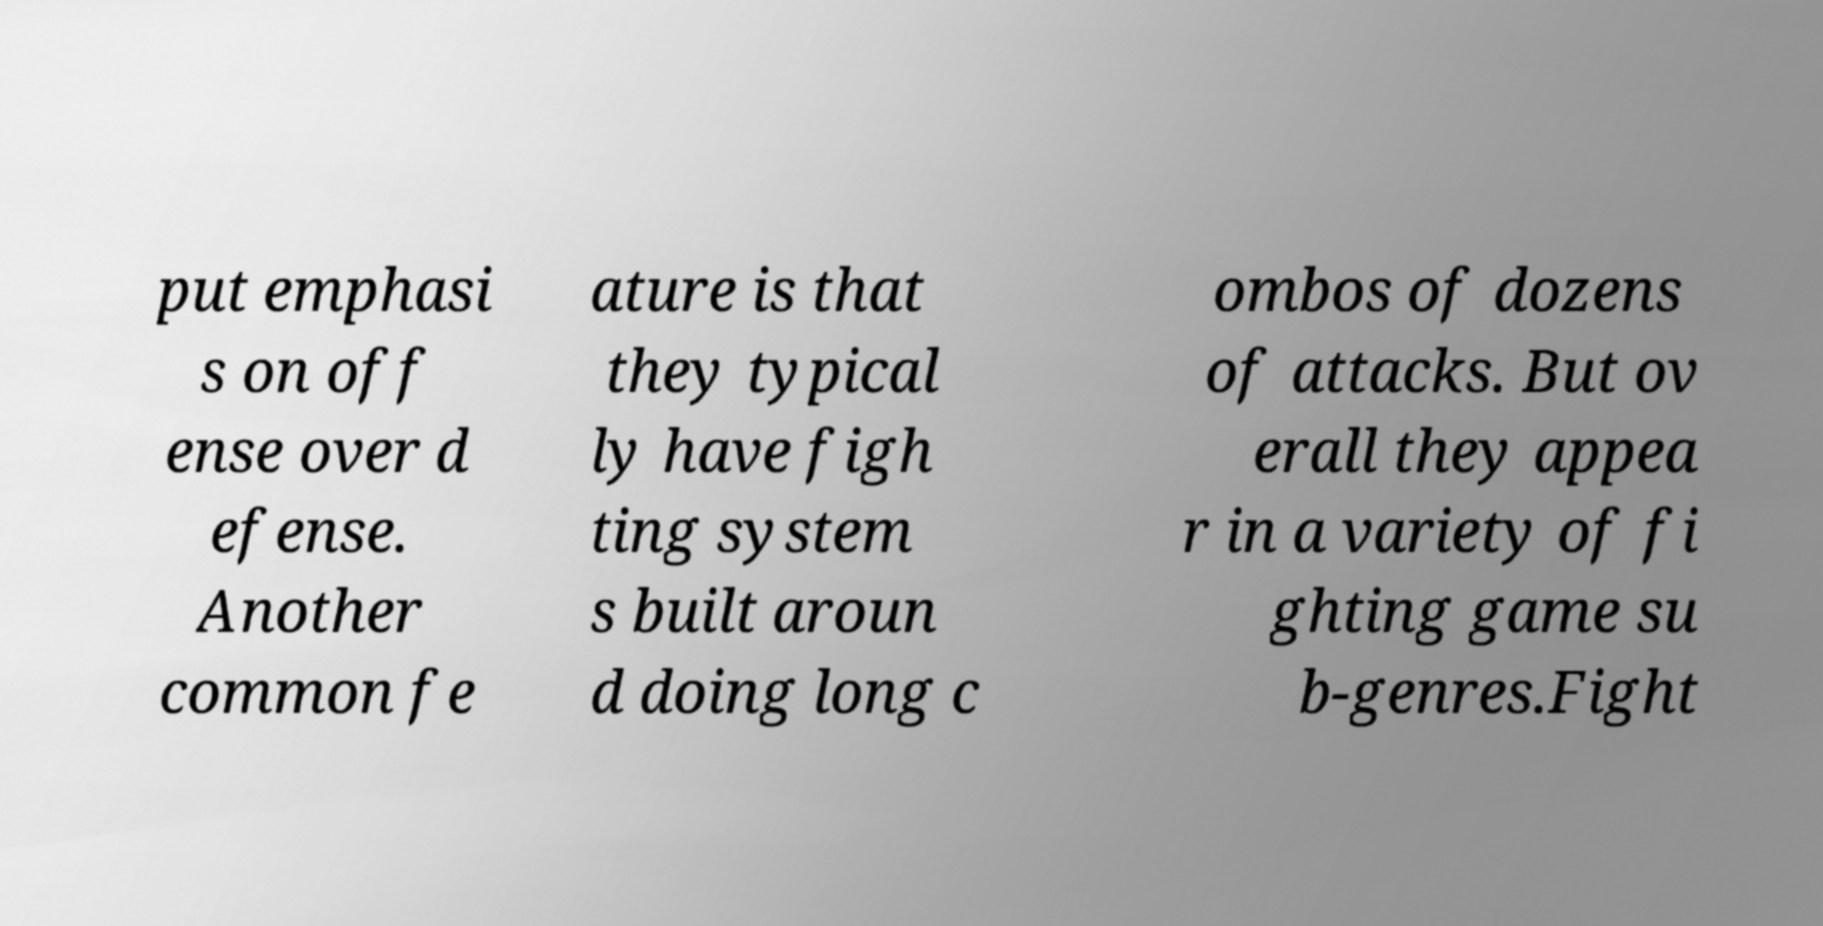Please identify and transcribe the text found in this image. put emphasi s on off ense over d efense. Another common fe ature is that they typical ly have figh ting system s built aroun d doing long c ombos of dozens of attacks. But ov erall they appea r in a variety of fi ghting game su b-genres.Fight 